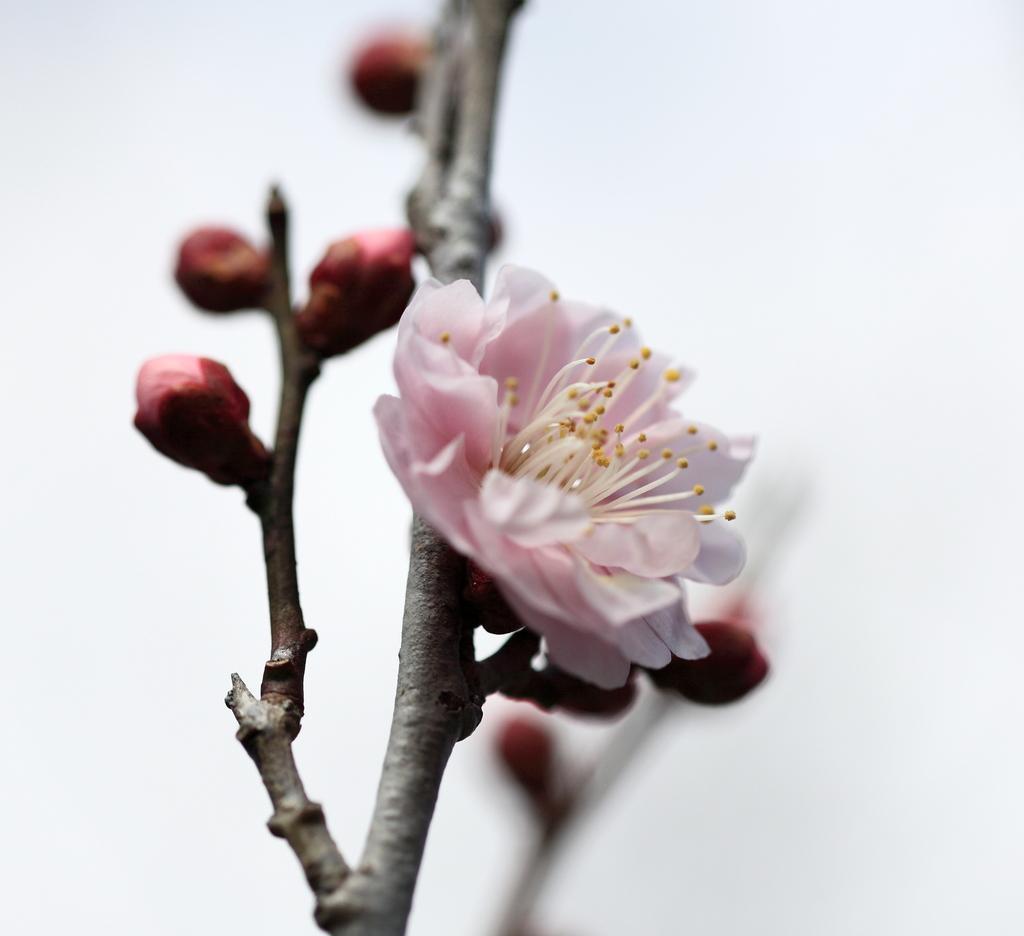Can you describe this image briefly? In this picture we can see a flower and a few buds. Background is white in color. 